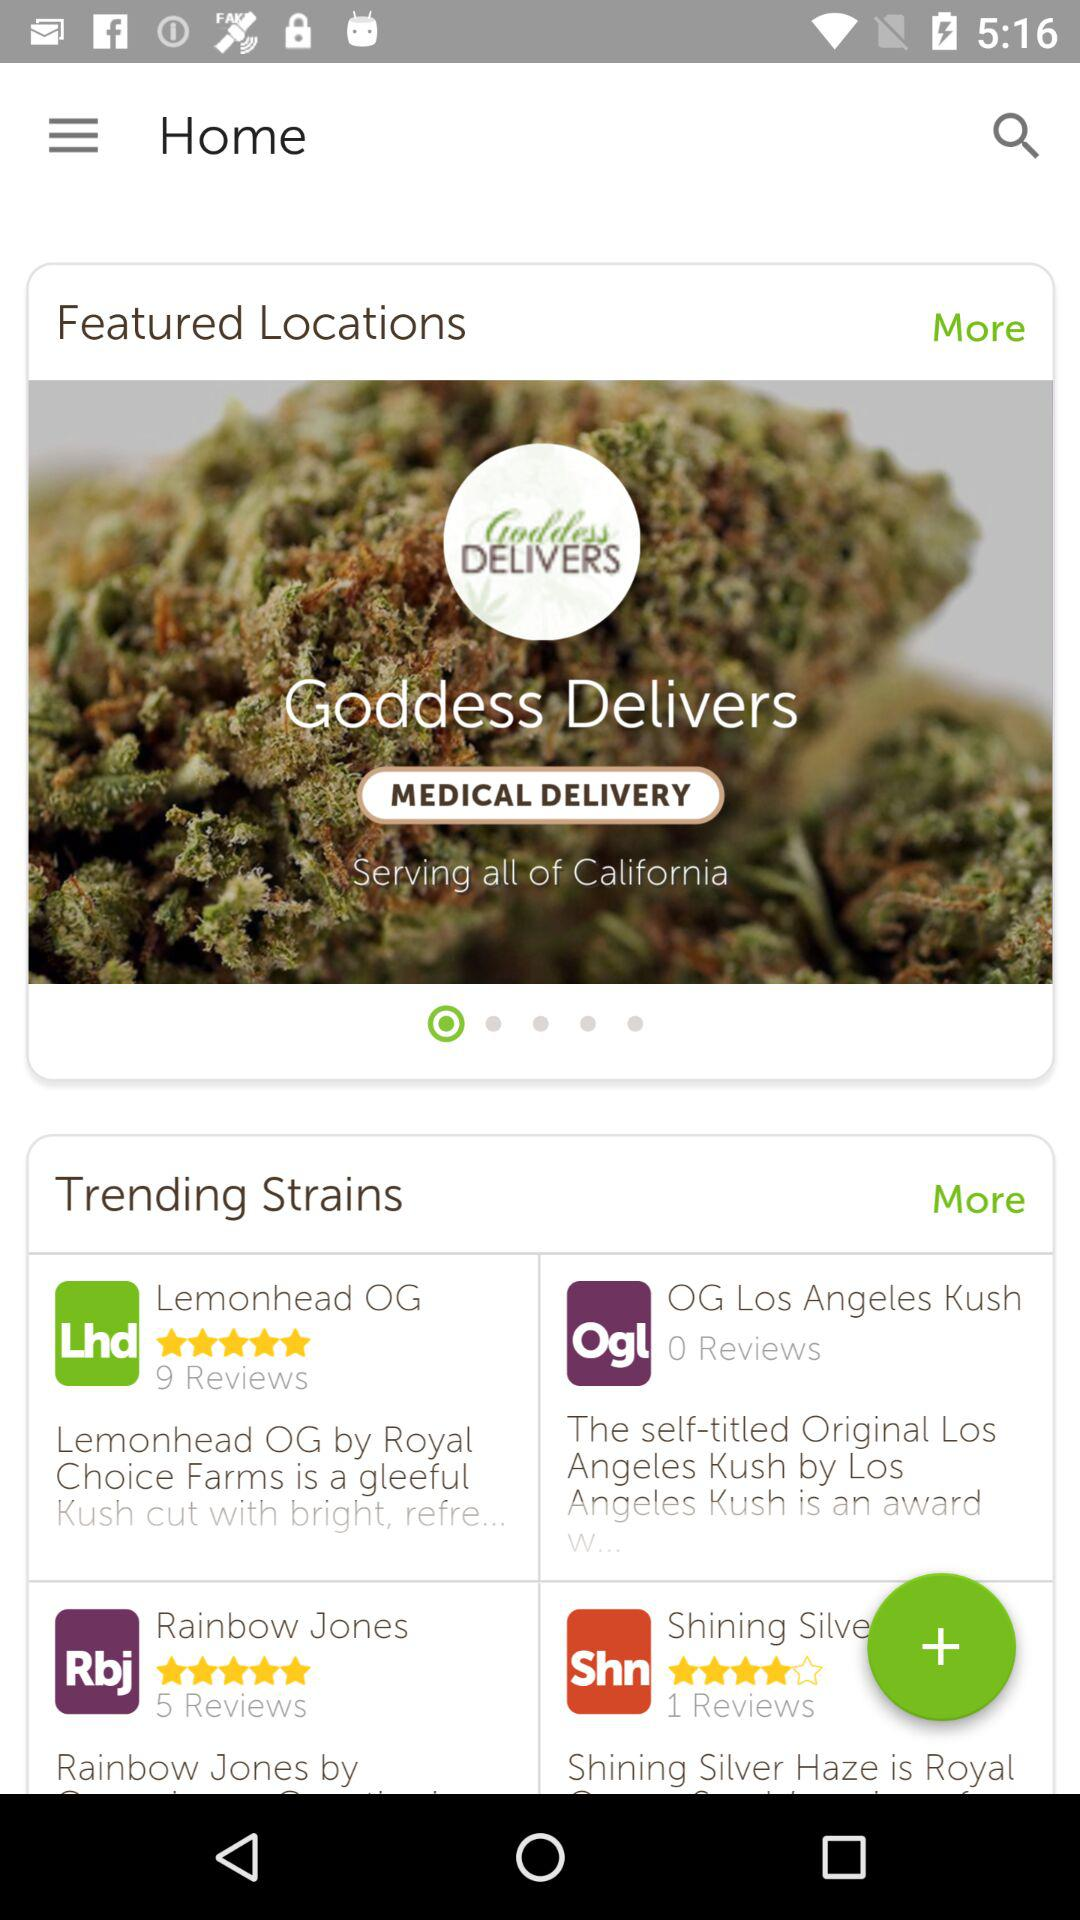What is the total number of reviewers for the Rainbow Jones? The total number of reviewers is 5. 